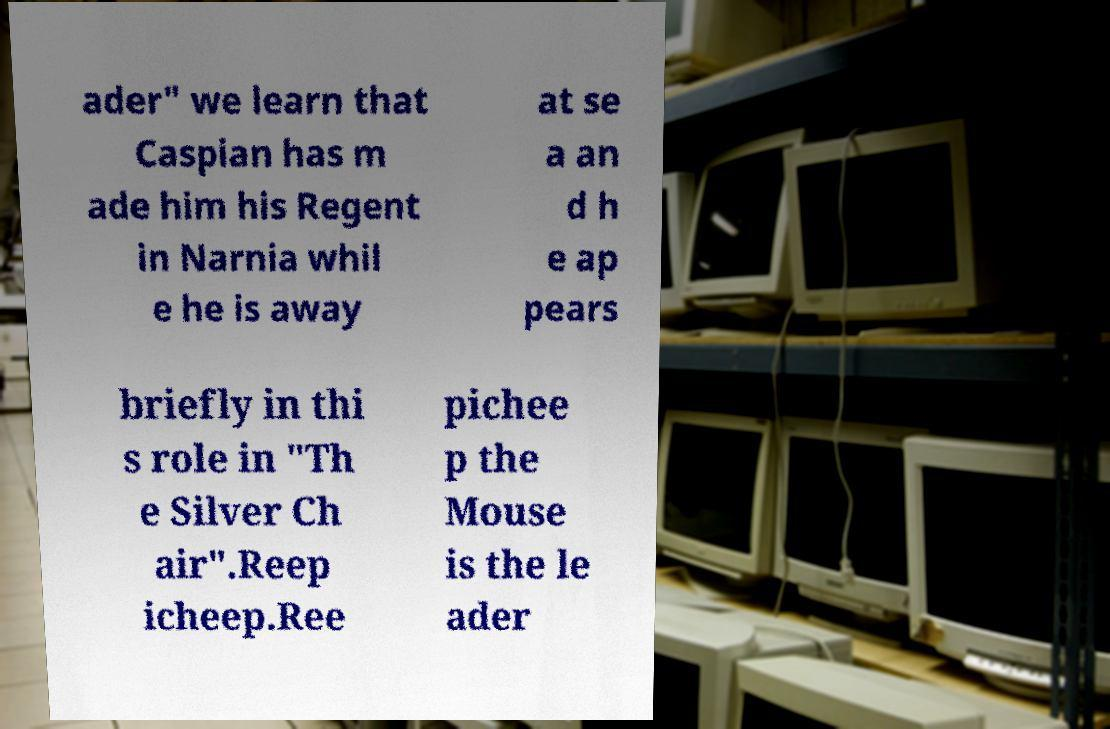What messages or text are displayed in this image? I need them in a readable, typed format. ader" we learn that Caspian has m ade him his Regent in Narnia whil e he is away at se a an d h e ap pears briefly in thi s role in "Th e Silver Ch air".Reep icheep.Ree pichee p the Mouse is the le ader 